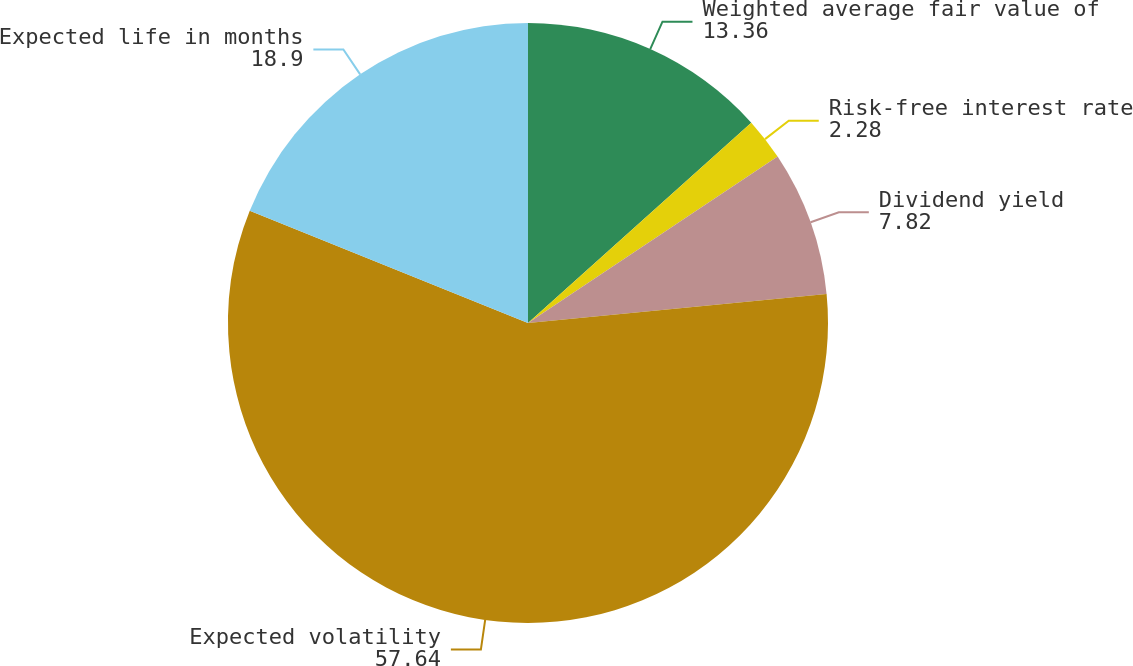Convert chart to OTSL. <chart><loc_0><loc_0><loc_500><loc_500><pie_chart><fcel>Weighted average fair value of<fcel>Risk-free interest rate<fcel>Dividend yield<fcel>Expected volatility<fcel>Expected life in months<nl><fcel>13.36%<fcel>2.28%<fcel>7.82%<fcel>57.64%<fcel>18.9%<nl></chart> 